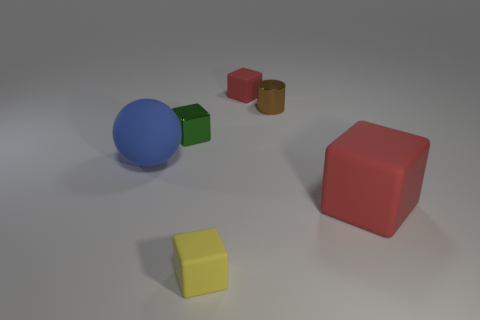Subtract all blue cubes. Subtract all yellow cylinders. How many cubes are left? 4 Add 1 big brown cubes. How many objects exist? 7 Subtract all cubes. How many objects are left? 2 Add 5 small brown metal cylinders. How many small brown metal cylinders are left? 6 Add 6 large purple rubber cubes. How many large purple rubber cubes exist? 6 Subtract 0 cyan cubes. How many objects are left? 6 Subtract all cylinders. Subtract all big red rubber objects. How many objects are left? 4 